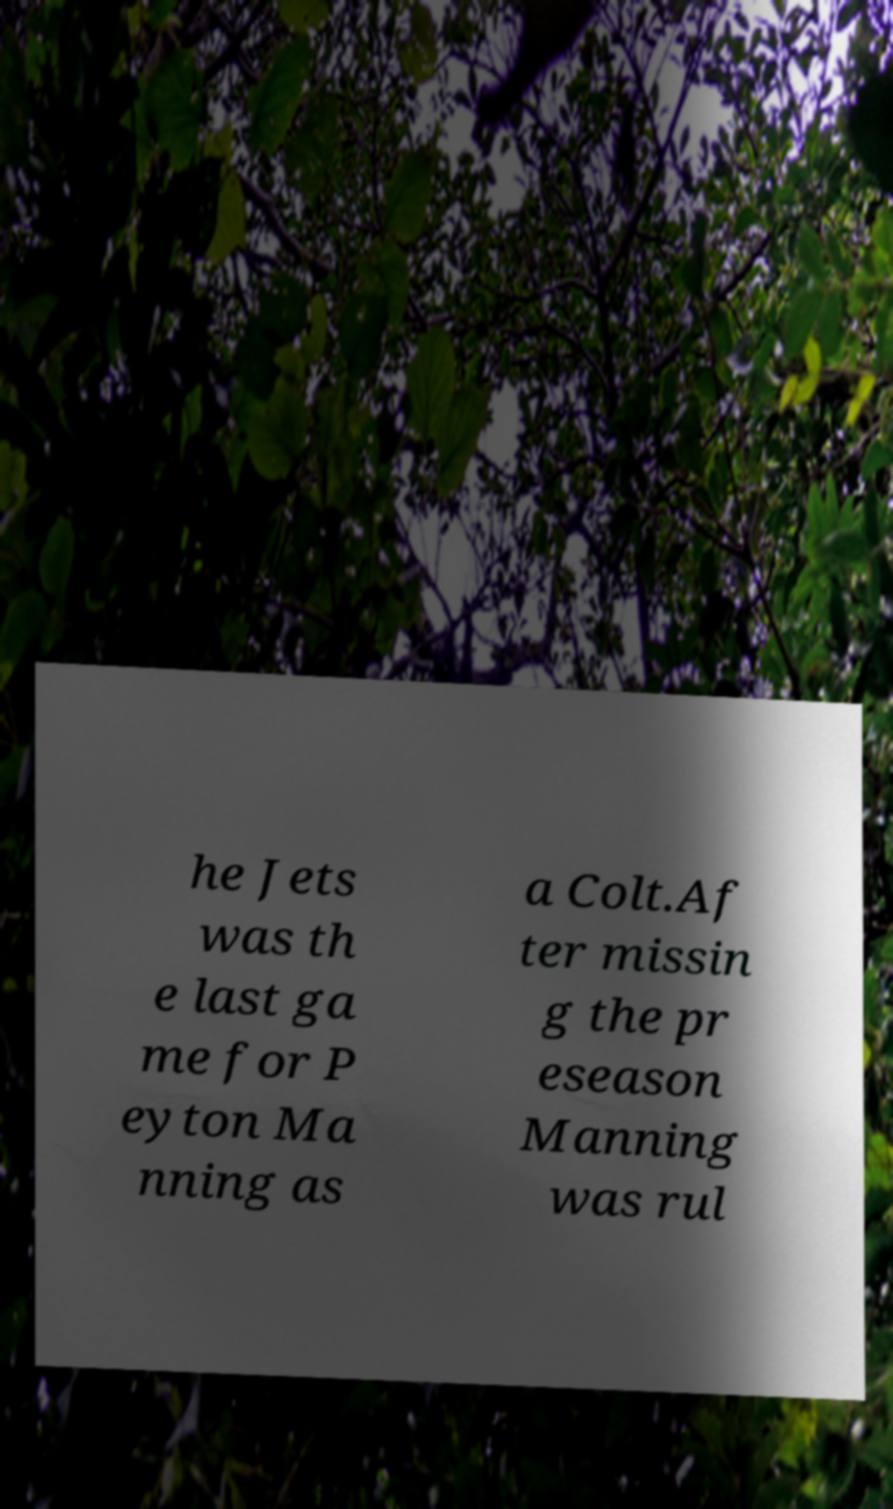For documentation purposes, I need the text within this image transcribed. Could you provide that? he Jets was th e last ga me for P eyton Ma nning as a Colt.Af ter missin g the pr eseason Manning was rul 